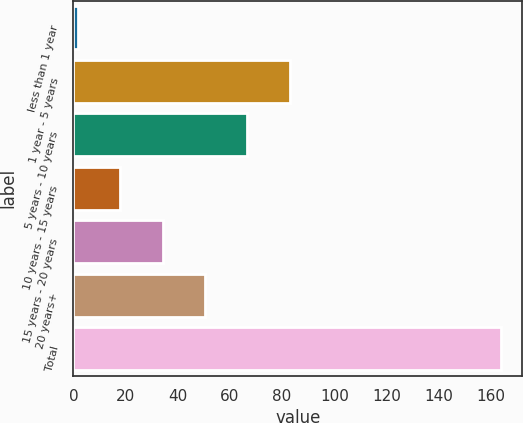Convert chart. <chart><loc_0><loc_0><loc_500><loc_500><bar_chart><fcel>less than 1 year<fcel>1 year - 5 years<fcel>5 years - 10 years<fcel>10 years - 15 years<fcel>15 years - 20 years<fcel>20 years+<fcel>Total<nl><fcel>1.8<fcel>82.85<fcel>66.64<fcel>18.01<fcel>34.22<fcel>50.43<fcel>163.9<nl></chart> 